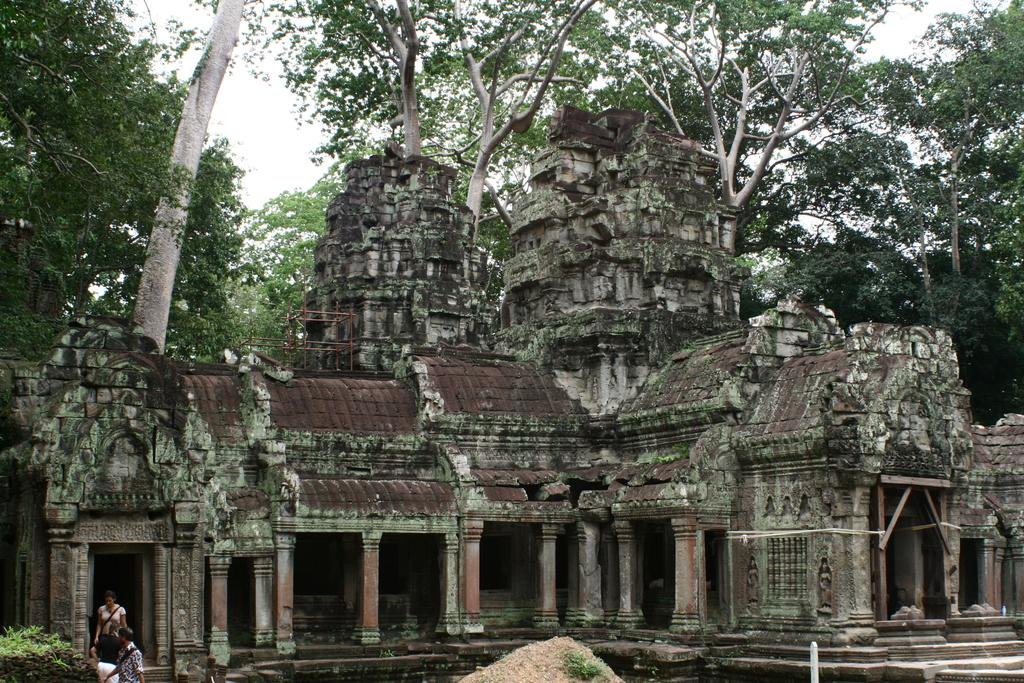What type of structure is in the image? There is an ancient temple in the image. What is the ground made of in the image? There is sand visible at the bottom of the image. How many people are in the image? There are three persons standing in the image. What type of vegetation is present in the image? There are plants in the image. What can be seen in the background of the image? There are trees and the sky visible in the background of the image. What type of yarn is being used to create the art in the image? There is no art or yarn present in the image; it features an ancient temple, sand, people, plants, trees, and the sky. 